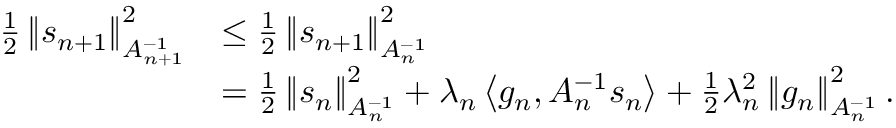<formula> <loc_0><loc_0><loc_500><loc_500>\begin{array} { r l } { \frac { 1 } { 2 } \left \| s _ { n + 1 } \right \| _ { A _ { n + 1 } ^ { - 1 } } ^ { 2 } } & { \leq \frac { 1 } { 2 } \left \| s _ { n + 1 } \right \| _ { A _ { n } ^ { - 1 } } ^ { 2 } } \\ & { = \frac { 1 } { 2 } \left \| s _ { n } \right \| _ { A _ { n } ^ { - 1 } } ^ { 2 } + \lambda _ { n } \left \langle g _ { n } , A _ { n } ^ { - 1 } s _ { n } \right \rangle + \frac { 1 } { 2 } \lambda _ { n } ^ { 2 } \left \| g _ { n } \right \| _ { A _ { n } ^ { - 1 } } ^ { 2 } . } \end{array}</formula> 